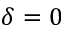Convert formula to latex. <formula><loc_0><loc_0><loc_500><loc_500>\delta = 0</formula> 